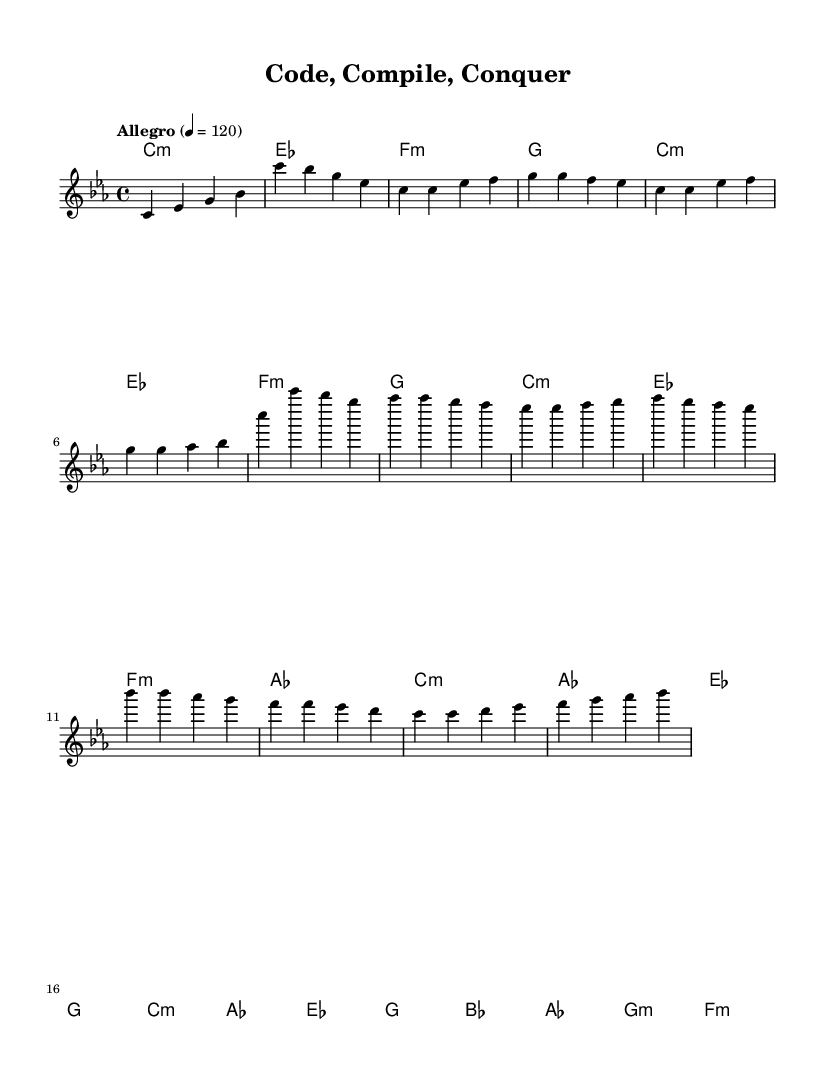What is the key signature of this music? The key signature is C minor, which contains three flats: B flat, E flat, and A flat. This is indicated at the beginning of the sheet music next to the clef.
Answer: C minor What is the time signature of this music? The time signature is 4/4, often referred to as "common time". This is indicated at the beginning of the sheet music, showing four beats per measure with a quarter note receiving one beat.
Answer: 4/4 What is the tempo marking for this piece? The tempo marking indicates that the piece should be played at "Allegro" at a speed of 120 beats per minute, as shown at the beginning of the sheet music underneath the time signature.
Answer: Allegro, 120 How many measures are in the chorus section? The chorus section consists of four measures, identifiable by counting the bars in the melody line designated for the chorus.
Answer: 4 What type of music is "Code, Compile, Conquer"? The title and the rhythmic structure of the piece, along with its thematic content, indicate it is a rap anthem, which often focuses on themes of ambition and hustle, suitable for the software development context addressed.
Answer: Rap Which chord is the first chord in the bridge? The first chord in the bridge is B flat major, which is shown as the first chord in the corresponding chord line.
Answer: B flat 